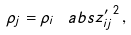Convert formula to latex. <formula><loc_0><loc_0><loc_500><loc_500>\rho _ { j } = \rho _ { i } \, \ a b s { z ^ { \prime } _ { i j } } ^ { 2 } \, ,</formula> 